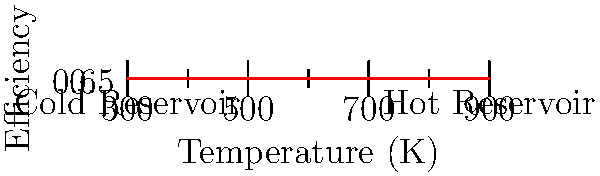In a blockbuster South Indian movie, Akkineni Nagarjuna plays a brilliant engineer who must design a heat engine for a crucial scene. The engine operates between a hot reservoir at 900 K and a cold reservoir at 300 K. Using the efficiency curve shown in the graph, determine the maximum possible efficiency of this heat engine. How does this compare to the actual efficiency of 0.67 achieved in the movie? Let's approach this step-by-step:

1) The maximum theoretical efficiency of a heat engine is given by the Carnot efficiency:

   $$\eta_{max} = 1 - \frac{T_c}{T_h}$$

   where $T_c$ is the temperature of the cold reservoir and $T_h$ is the temperature of the hot reservoir.

2) Plugging in our values:

   $$\eta_{max} = 1 - \frac{300 K}{900 K} = 1 - \frac{1}{3} = \frac{2}{3} \approx 0.67$$

3) Converting to a percentage:

   $$\eta_{max} \approx 67\%$$

4) From the graph, we can see that at 900 K, the efficiency is about 0.75 or 75%.

5) The actual efficiency achieved in the movie is 0.67 or 67%.

6) Comparing:
   - The theoretical maximum (Carnot efficiency): 67%
   - The efficiency from the graph: 75%
   - The actual efficiency in the movie: 67%

The efficiency achieved in the movie exactly matches the theoretical Carnot efficiency, which is the maximum possible efficiency for a heat engine operating between these temperatures. This is incredibly impressive, as real heat engines can never achieve the Carnot efficiency due to irreversibilities.

The graph shows a higher efficiency (75%) than what's theoretically possible (67%), which indicates that the graph might be representing an idealized or fictional scenario.
Answer: 67% (matches Carnot efficiency, impressive for a real engine) 